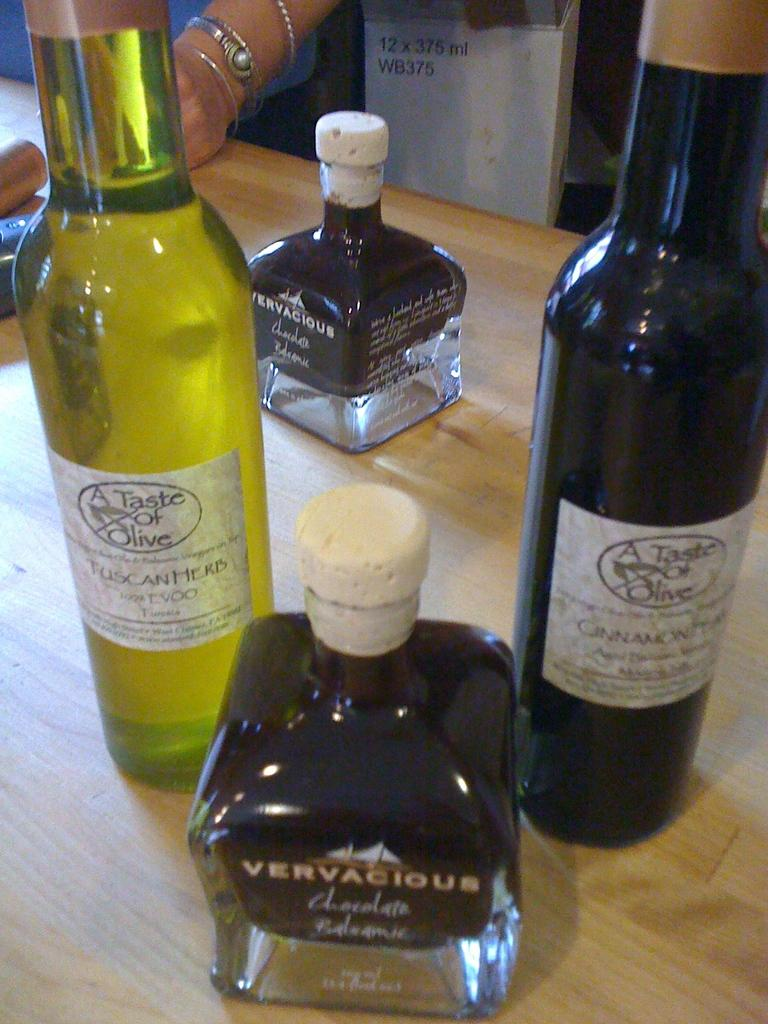<image>
Give a short and clear explanation of the subsequent image. Several unopened bottles on a table, including A Taste of Olive. 